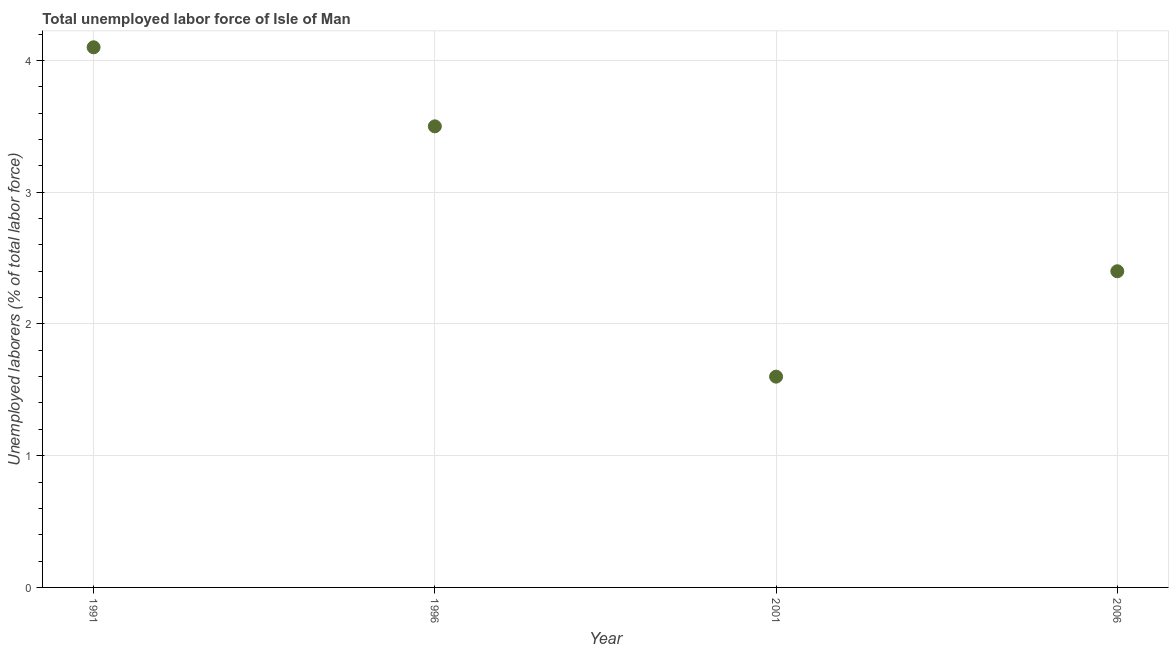What is the total unemployed labour force in 1991?
Offer a very short reply. 4.1. Across all years, what is the maximum total unemployed labour force?
Your response must be concise. 4.1. Across all years, what is the minimum total unemployed labour force?
Offer a terse response. 1.6. In which year was the total unemployed labour force minimum?
Offer a terse response. 2001. What is the sum of the total unemployed labour force?
Your answer should be compact. 11.6. What is the difference between the total unemployed labour force in 1996 and 2001?
Your answer should be compact. 1.9. What is the average total unemployed labour force per year?
Keep it short and to the point. 2.9. What is the median total unemployed labour force?
Your answer should be very brief. 2.95. Do a majority of the years between 2006 and 1991 (inclusive) have total unemployed labour force greater than 2.2 %?
Your response must be concise. Yes. What is the ratio of the total unemployed labour force in 1991 to that in 2001?
Your response must be concise. 2.56. Is the total unemployed labour force in 1991 less than that in 2001?
Provide a succinct answer. No. Is the difference between the total unemployed labour force in 2001 and 2006 greater than the difference between any two years?
Offer a very short reply. No. What is the difference between the highest and the second highest total unemployed labour force?
Your response must be concise. 0.6. What is the difference between the highest and the lowest total unemployed labour force?
Provide a short and direct response. 2.5. Does the total unemployed labour force monotonically increase over the years?
Make the answer very short. No. How many dotlines are there?
Make the answer very short. 1. What is the difference between two consecutive major ticks on the Y-axis?
Keep it short and to the point. 1. Does the graph contain any zero values?
Provide a short and direct response. No. What is the title of the graph?
Ensure brevity in your answer.  Total unemployed labor force of Isle of Man. What is the label or title of the Y-axis?
Offer a very short reply. Unemployed laborers (% of total labor force). What is the Unemployed laborers (% of total labor force) in 1991?
Make the answer very short. 4.1. What is the Unemployed laborers (% of total labor force) in 1996?
Offer a very short reply. 3.5. What is the Unemployed laborers (% of total labor force) in 2001?
Your answer should be very brief. 1.6. What is the Unemployed laborers (% of total labor force) in 2006?
Give a very brief answer. 2.4. What is the difference between the Unemployed laborers (% of total labor force) in 1991 and 1996?
Offer a very short reply. 0.6. What is the difference between the Unemployed laborers (% of total labor force) in 1991 and 2001?
Your answer should be very brief. 2.5. What is the ratio of the Unemployed laborers (% of total labor force) in 1991 to that in 1996?
Ensure brevity in your answer.  1.17. What is the ratio of the Unemployed laborers (% of total labor force) in 1991 to that in 2001?
Offer a terse response. 2.56. What is the ratio of the Unemployed laborers (% of total labor force) in 1991 to that in 2006?
Ensure brevity in your answer.  1.71. What is the ratio of the Unemployed laborers (% of total labor force) in 1996 to that in 2001?
Your response must be concise. 2.19. What is the ratio of the Unemployed laborers (% of total labor force) in 1996 to that in 2006?
Offer a very short reply. 1.46. What is the ratio of the Unemployed laborers (% of total labor force) in 2001 to that in 2006?
Your response must be concise. 0.67. 